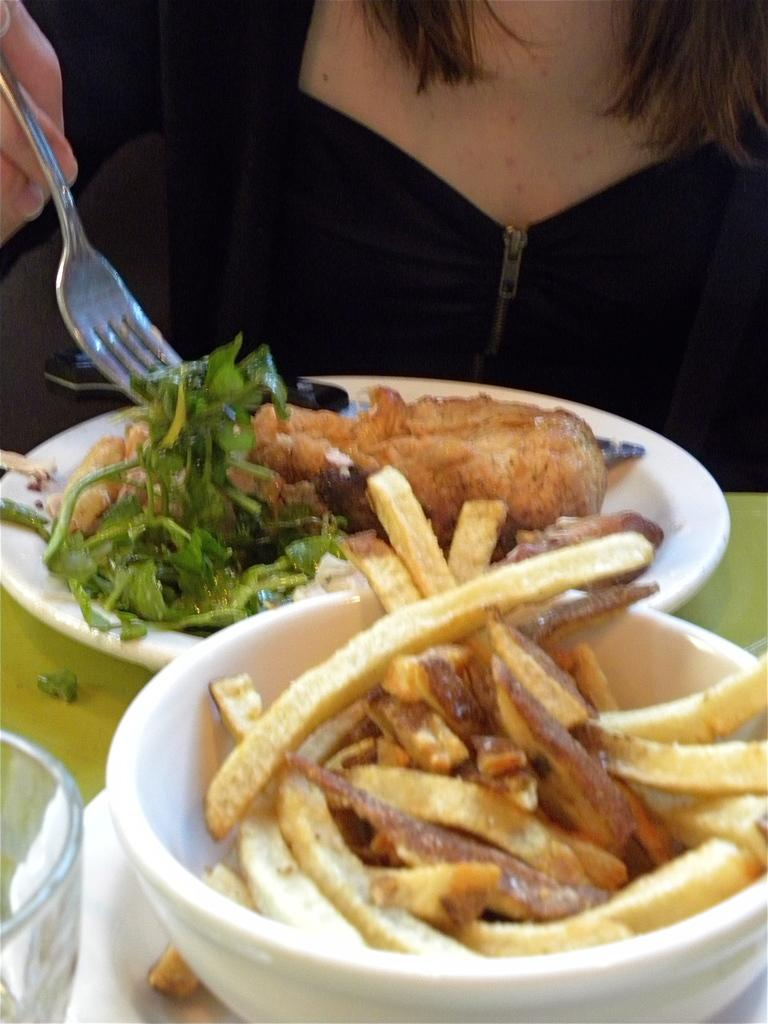Who is present in the image? There is a woman in the image. What is the woman holding in the image? The woman is holding a fork. What type of food can be seen in the image? There is food in a plate and french fries in a bowl in the image. What other items are present on the table? There is a glass on the table. How many pigs are present in the image? There are no pigs present in the image. What type of company is the woman representing in the image? The image does not provide any information about the company the woman might be representing. 